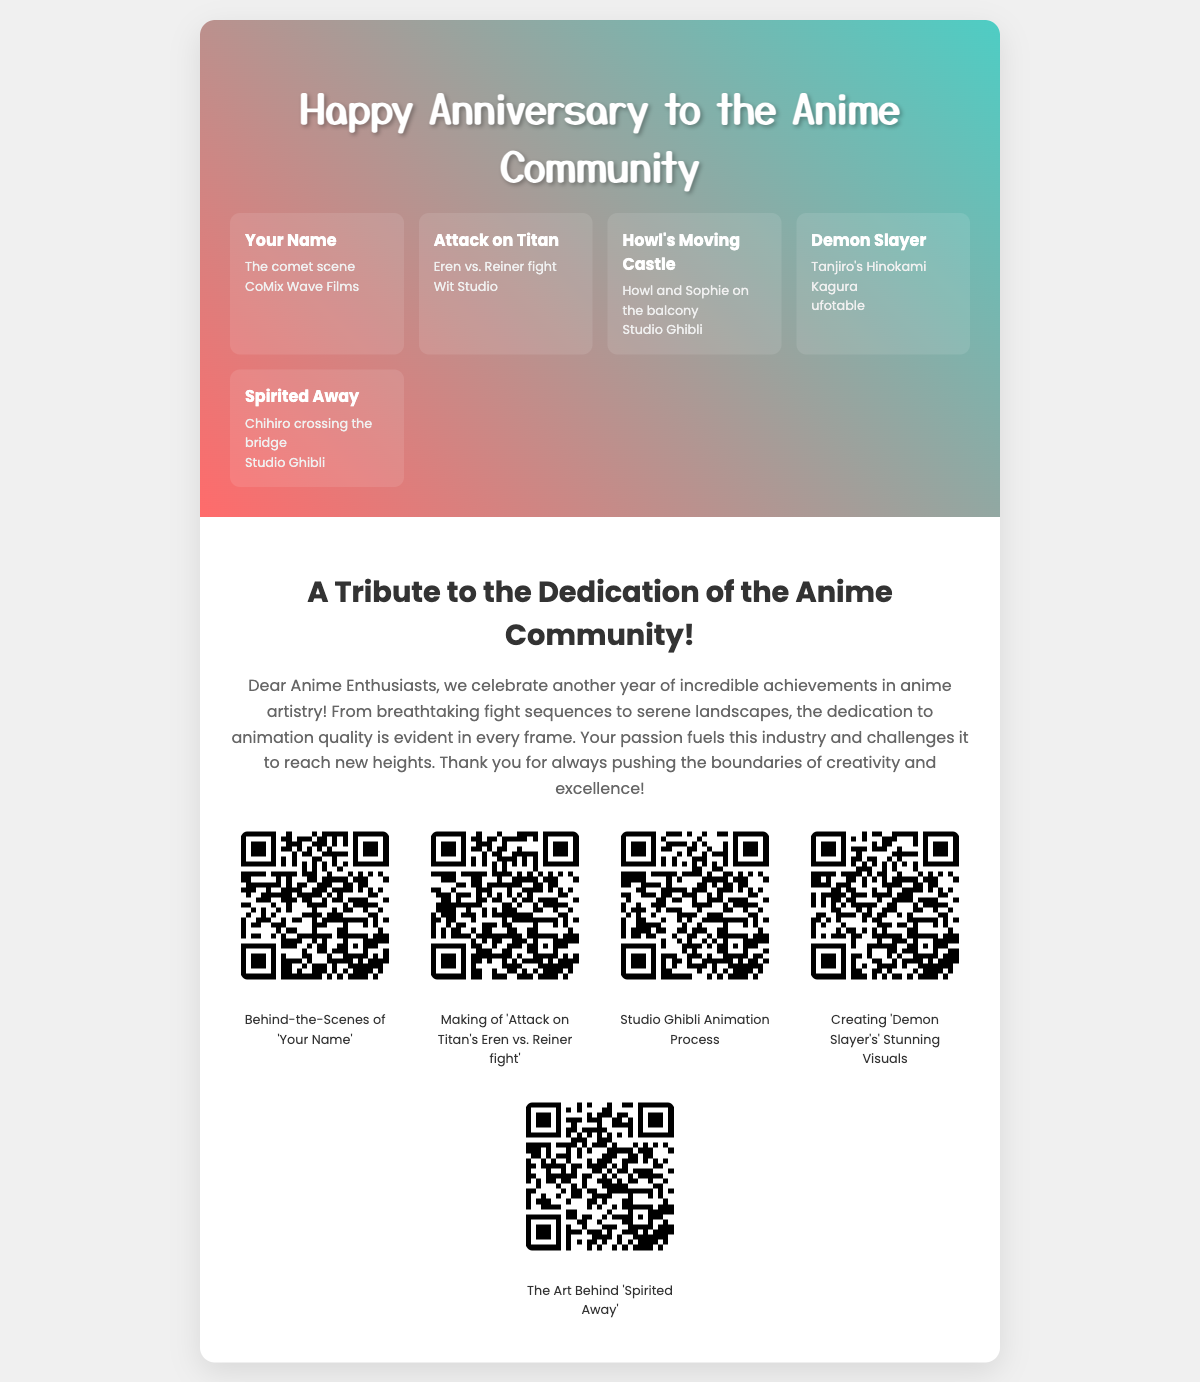What is the title of the card? The title of the card is prominently displayed at the top of the cover section.
Answer: Happy Anniversary to the Anime Community How many iconic anime scenes are displayed on the cover? The cover showcases a total of five iconic anime scenes, each contributing to the collage.
Answer: 5 Which anime features the scene with "Eren vs. Reiner fight"? This specific scene is from a well-known anime that gained popularity for its intense action sequences.
Answer: Attack on Titan What message is included inside the card? The inside of the card contains a tribute message dedicated to the anime community.
Answer: A Tribute to the Dedication of the Anime Community! What type of content can be accessed with the QR codes? The QR codes provide a link to exclusive content related to the making of various anime.
Answer: Behind-the-scenes content and animation making-of videos Which studio animated "Howl's Moving Castle"? The studio responsible for creating this beloved film is credited on the cover.
Answer: Studio Ghibli What is the theme of the tribute message? The tribute message emphasizes the dedication and achievements of anime artistry over the years.
Answer: Dedication to animation quality What color scheme is used in the card design? The color scheme features a vibrant and eye-catching combination that is used throughout the cover.
Answer: Linear gradient with pink and teal colors 